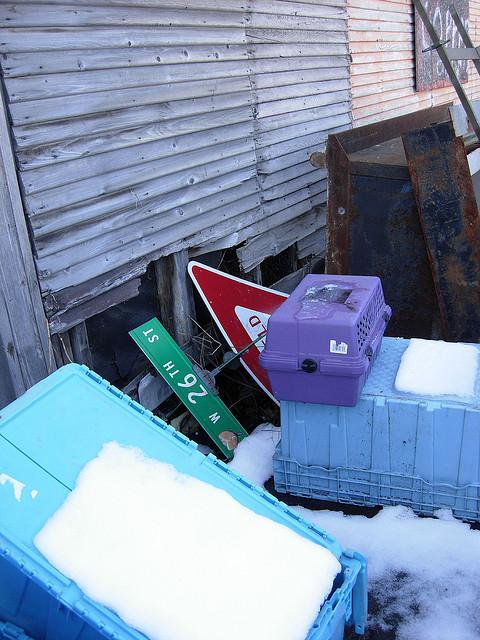What is the name of the street that the sign is for?
Give a very brief answer. W 26th st. What shape is the red and white sign?
Write a very short answer. Triangle. Is the purple box for a cat?
Be succinct. Yes. 